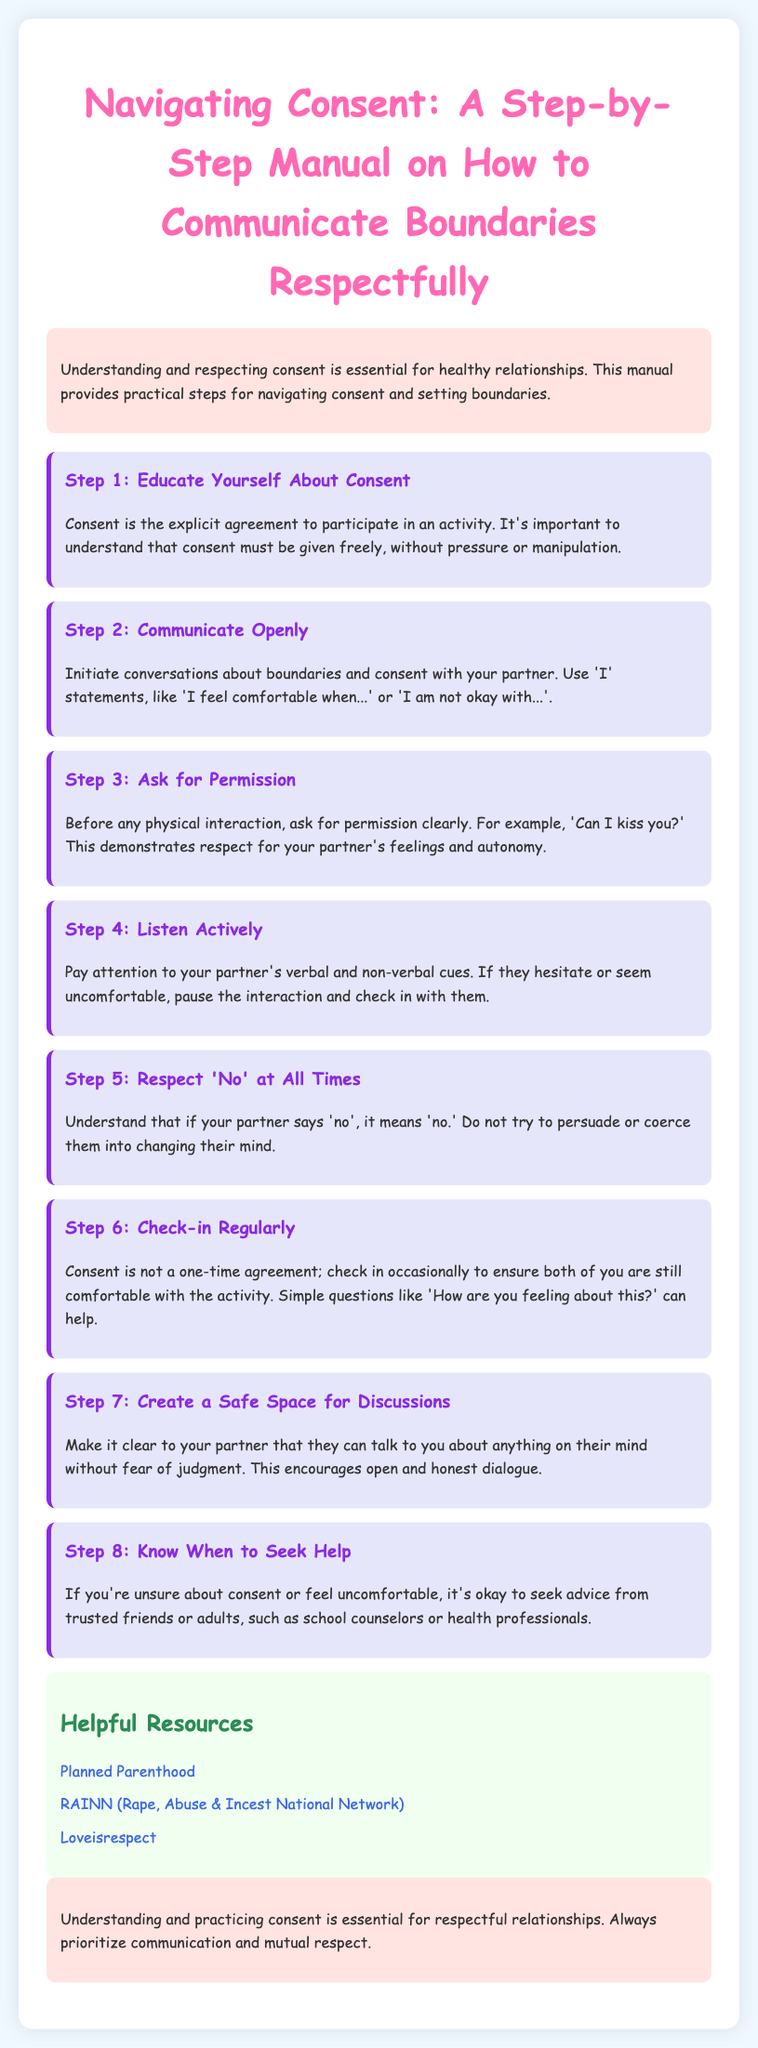What is the title of the manual? The title summarizes the content of the document focused on consent and communication.
Answer: Navigating Consent: A Step-by-Step Manual on How to Communicate Boundaries Respectfully What is the first step in navigating consent? The first step outlines the initial action one should take regarding consent according to the manual.
Answer: Educate Yourself About Consent What should you use when communicating your feelings? This emphasizes the specific type of statements recommended for open communication.
Answer: 'I' statements What is the recommended action if your partner says 'no'? This highlights the specific guideline for respecting boundaries in the manual.
Answer: Respect 'No' at All Times How many steps are outlined in the manual? This quantifies the number of distinct actions to take regarding consent mentioned in the document.
Answer: Eight What is the suggested action for checking in with your partner? This outlines the specific type of communication recommended for maintaining consent.
Answer: Ask simple questions Which organization is listed as a helpful resource? This identifies one specific external source recommended in the resources section of the document.
Answer: Planned Parenthood What type of space should you aim to create for discussions? This identifies the environment one should foster for effective communication regarding consent.
Answer: Safe Space When should you seek help according to the manual? This specifies the situation when reaching out for advice or support is encouraged.
Answer: If you're unsure about consent 